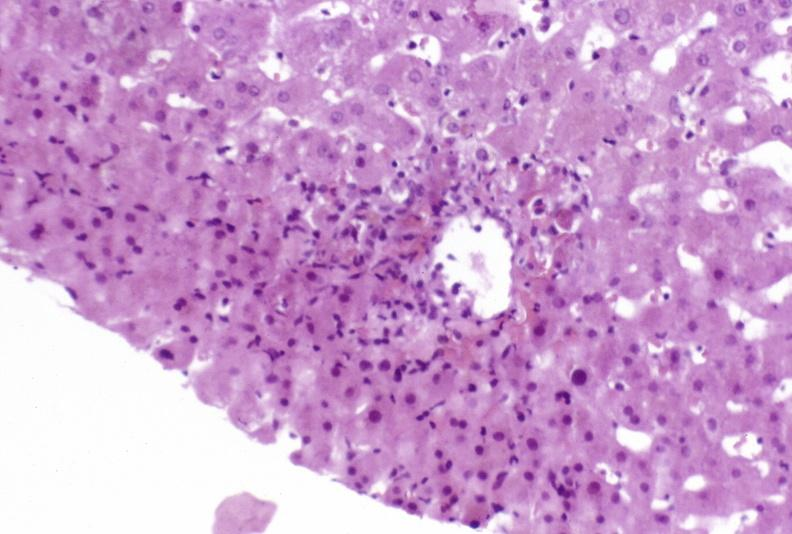s blood present?
Answer the question using a single word or phrase. No 